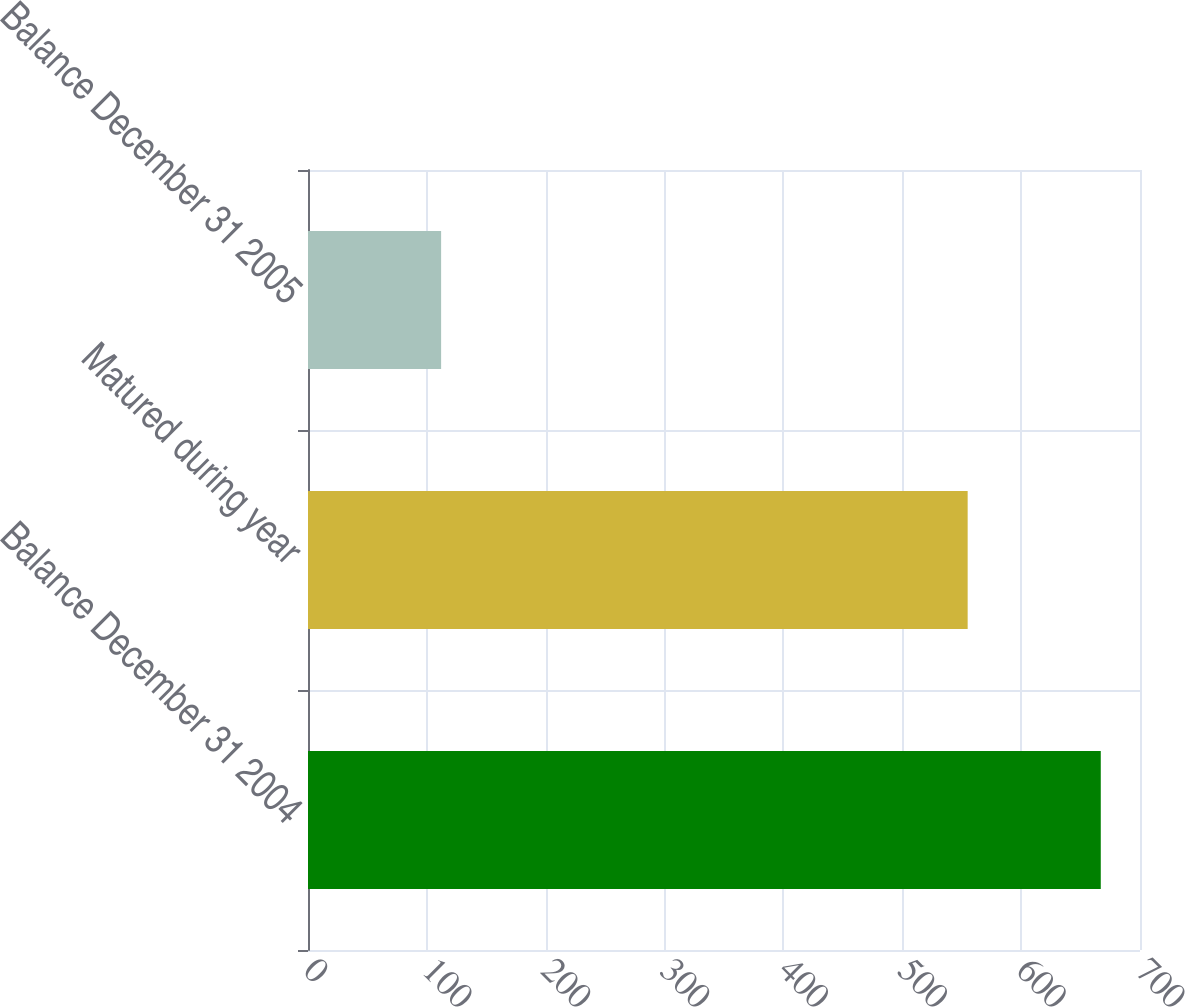Convert chart to OTSL. <chart><loc_0><loc_0><loc_500><loc_500><bar_chart><fcel>Balance December 31 2004<fcel>Matured during year<fcel>Balance December 31 2005<nl><fcel>667<fcel>555<fcel>112<nl></chart> 